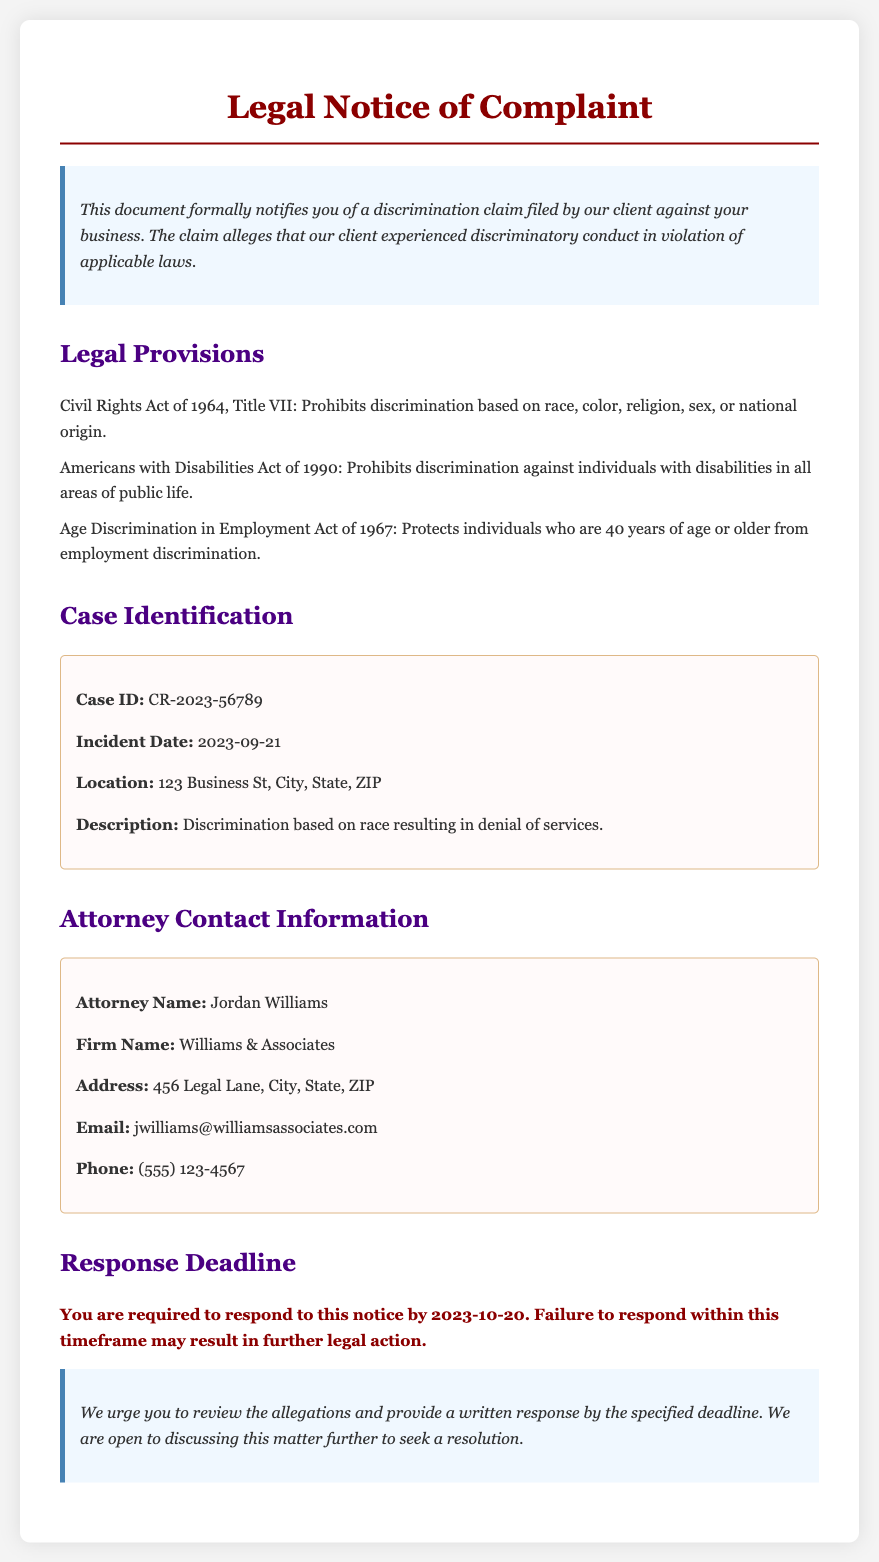What is the title of the document? The title of the document is found in the header section.
Answer: Legal Notice of Complaint What is the case ID? The case ID is specified in the case identification section.
Answer: CR-2023-56789 Who is the attorney representing the client? The attorney's name is listed in the attorney contact information section.
Answer: Jordan Williams What is the description of the incident? The incident description is provided in the case identification section.
Answer: Discrimination based on race resulting in denial of services What is the response deadline? The response deadline is highlighted in the response deadline section.
Answer: 2023-10-20 Which act prohibits discrimination based on age? The relevant legal provision can be found in the legal provisions section.
Answer: Age Discrimination in Employment Act of 1967 Where is the attorney's firm located? The firm's address is provided in the attorney contact information section.
Answer: 456 Legal Lane, City, State, ZIP What type of discrimination does the claim involve? This information is found in the incident description of the case.
Answer: Race 